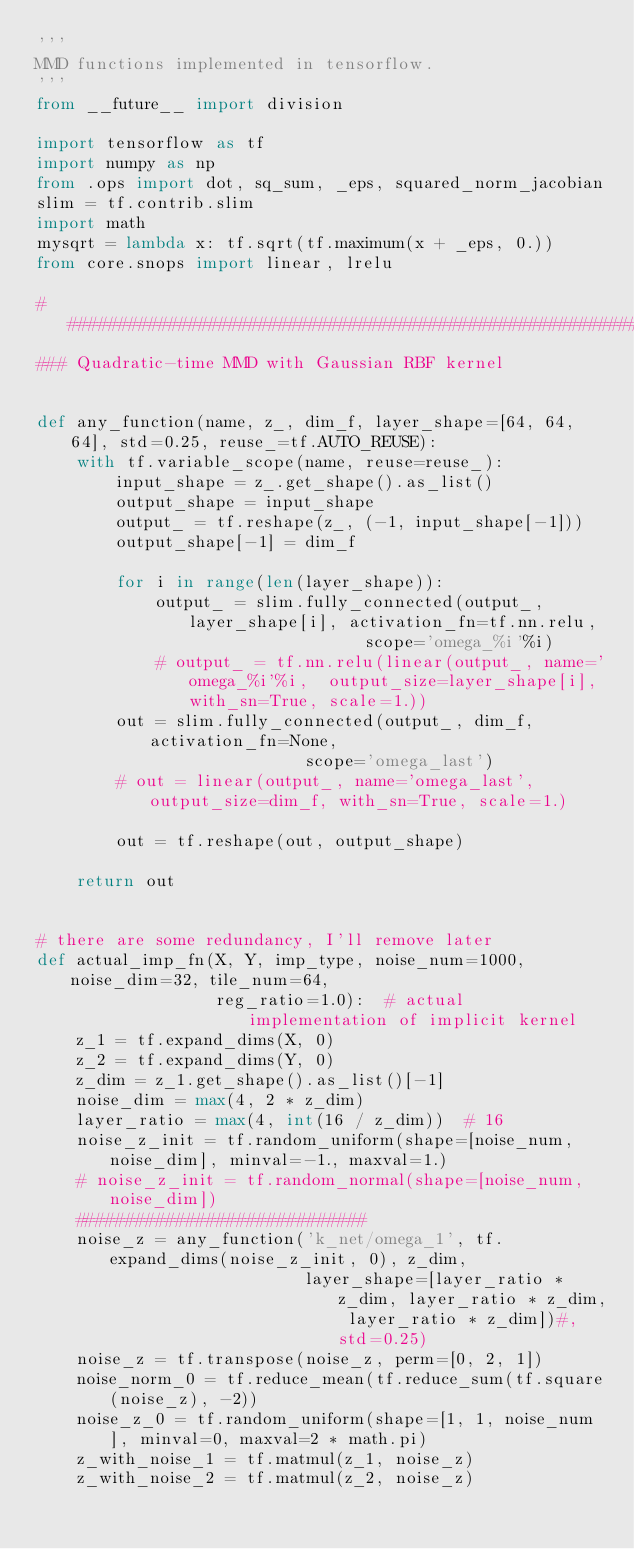<code> <loc_0><loc_0><loc_500><loc_500><_Python_>'''
MMD functions implemented in tensorflow.
'''
from __future__ import division

import tensorflow as tf
import numpy as np
from .ops import dot, sq_sum, _eps, squared_norm_jacobian
slim = tf.contrib.slim
import math
mysqrt = lambda x: tf.sqrt(tf.maximum(x + _eps, 0.))
from core.snops import linear, lrelu

################################################################################
### Quadratic-time MMD with Gaussian RBF kernel


def any_function(name, z_, dim_f, layer_shape=[64, 64, 64], std=0.25, reuse_=tf.AUTO_REUSE):
    with tf.variable_scope(name, reuse=reuse_):
        input_shape = z_.get_shape().as_list()
        output_shape = input_shape
        output_ = tf.reshape(z_, (-1, input_shape[-1]))
        output_shape[-1] = dim_f

        for i in range(len(layer_shape)):
            output_ = slim.fully_connected(output_, layer_shape[i], activation_fn=tf.nn.relu,
                                 scope='omega_%i'%i)
            # output_ = tf.nn.relu(linear(output_, name='omega_%i'%i,  output_size=layer_shape[i], with_sn=True, scale=1.))
        out = slim.fully_connected(output_, dim_f, activation_fn=None,
                           scope='omega_last')
        # out = linear(output_, name='omega_last', output_size=dim_f, with_sn=True, scale=1.)

        out = tf.reshape(out, output_shape)

    return out


# there are some redundancy, I'll remove later
def actual_imp_fn(X, Y, imp_type, noise_num=1000, noise_dim=32, tile_num=64,
                  reg_ratio=1.0):  # actual implementation of implicit kernel
    z_1 = tf.expand_dims(X, 0)
    z_2 = tf.expand_dims(Y, 0)
    z_dim = z_1.get_shape().as_list()[-1]
    noise_dim = max(4, 2 * z_dim)
    layer_ratio = max(4, int(16 / z_dim))  # 16
    noise_z_init = tf.random_uniform(shape=[noise_num, noise_dim], minval=-1., maxval=1.)
    # noise_z_init = tf.random_normal(shape=[noise_num, noise_dim])
    #############################
    noise_z = any_function('k_net/omega_1', tf.expand_dims(noise_z_init, 0), z_dim,
                           layer_shape=[layer_ratio * z_dim, layer_ratio * z_dim, layer_ratio * z_dim])#, std=0.25)
    noise_z = tf.transpose(noise_z, perm=[0, 2, 1])
    noise_norm_0 = tf.reduce_mean(tf.reduce_sum(tf.square(noise_z), -2))
    noise_z_0 = tf.random_uniform(shape=[1, 1, noise_num], minval=0, maxval=2 * math.pi)
    z_with_noise_1 = tf.matmul(z_1, noise_z)
    z_with_noise_2 = tf.matmul(z_2, noise_z)</code> 